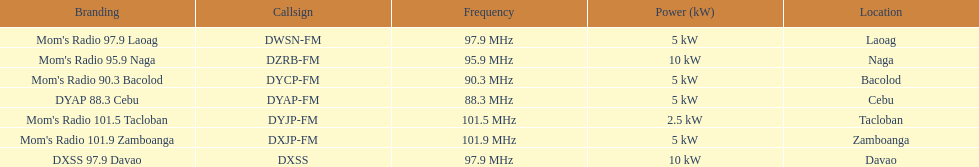How often does the frequency surpass 95? 5. Parse the full table. {'header': ['Branding', 'Callsign', 'Frequency', 'Power (kW)', 'Location'], 'rows': [["Mom's Radio 97.9 Laoag", 'DWSN-FM', '97.9\xa0MHz', '5\xa0kW', 'Laoag'], ["Mom's Radio 95.9 Naga", 'DZRB-FM', '95.9\xa0MHz', '10\xa0kW', 'Naga'], ["Mom's Radio 90.3 Bacolod", 'DYCP-FM', '90.3\xa0MHz', '5\xa0kW', 'Bacolod'], ['DYAP 88.3 Cebu', 'DYAP-FM', '88.3\xa0MHz', '5\xa0kW', 'Cebu'], ["Mom's Radio 101.5 Tacloban", 'DYJP-FM', '101.5\xa0MHz', '2.5\xa0kW', 'Tacloban'], ["Mom's Radio 101.9 Zamboanga", 'DXJP-FM', '101.9\xa0MHz', '5\xa0kW', 'Zamboanga'], ['DXSS 97.9 Davao', 'DXSS', '97.9\xa0MHz', '10\xa0kW', 'Davao']]} 